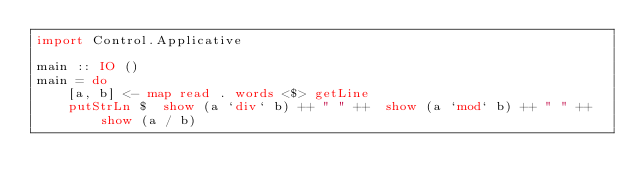<code> <loc_0><loc_0><loc_500><loc_500><_Haskell_>import Control.Applicative
 
main :: IO ()
main = do
    [a, b] <- map read . words <$> getLine
    putStrLn $  show (a `div` b) ++ " " ++  show (a `mod` b) ++ " " ++ show (a / b)</code> 